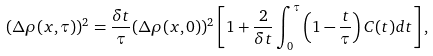<formula> <loc_0><loc_0><loc_500><loc_500>( \Delta \rho ( x , \tau ) ) ^ { 2 } = \frac { \delta t } { \tau } ( \Delta \rho ( x , 0 ) ) ^ { 2 } \left [ 1 + \frac { 2 } { \delta t } \int _ { 0 } ^ { \tau } \left ( 1 - \frac { t } { \tau } \right ) C ( t ) d t \right ] ,</formula> 